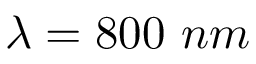<formula> <loc_0><loc_0><loc_500><loc_500>\lambda = 8 0 0 n m</formula> 